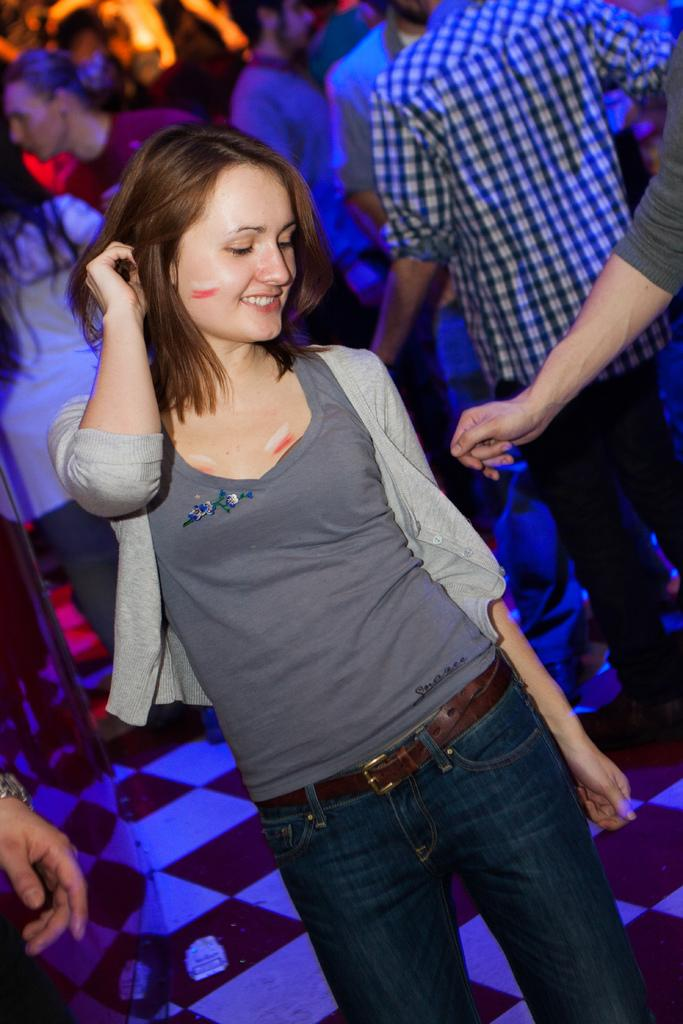What is the main subject of the image? The main subject of the image is people standing. Can you describe the location of the people in the image? The people are standing on the floor. What type of brush is being used by the mom in the image? There is no mom or brush present in the image. 